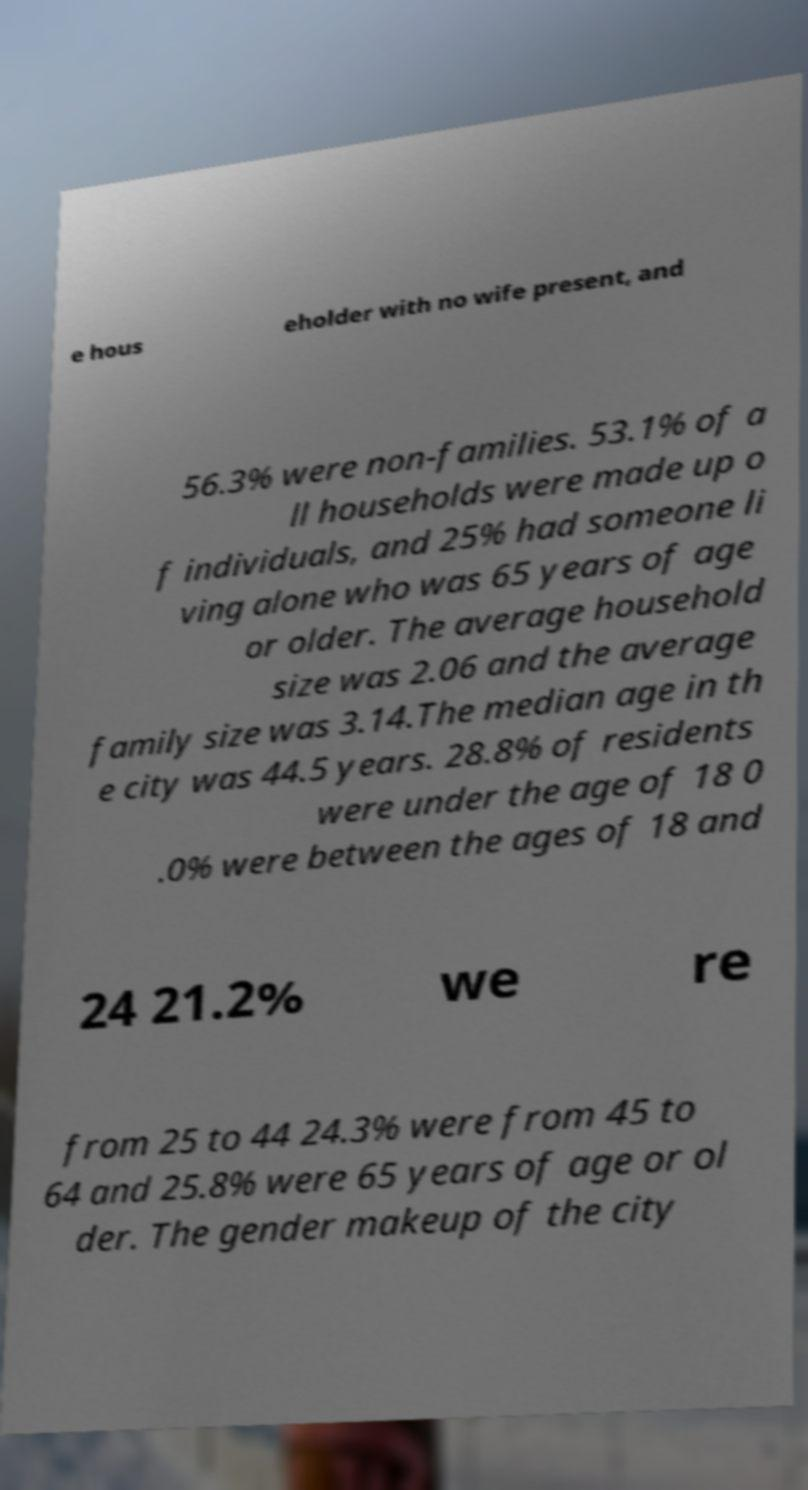Can you read and provide the text displayed in the image?This photo seems to have some interesting text. Can you extract and type it out for me? e hous eholder with no wife present, and 56.3% were non-families. 53.1% of a ll households were made up o f individuals, and 25% had someone li ving alone who was 65 years of age or older. The average household size was 2.06 and the average family size was 3.14.The median age in th e city was 44.5 years. 28.8% of residents were under the age of 18 0 .0% were between the ages of 18 and 24 21.2% we re from 25 to 44 24.3% were from 45 to 64 and 25.8% were 65 years of age or ol der. The gender makeup of the city 